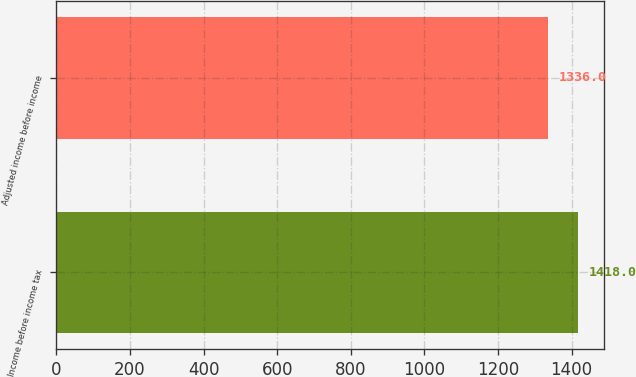<chart> <loc_0><loc_0><loc_500><loc_500><bar_chart><fcel>Income before income tax<fcel>Adjusted income before income<nl><fcel>1418<fcel>1336<nl></chart> 